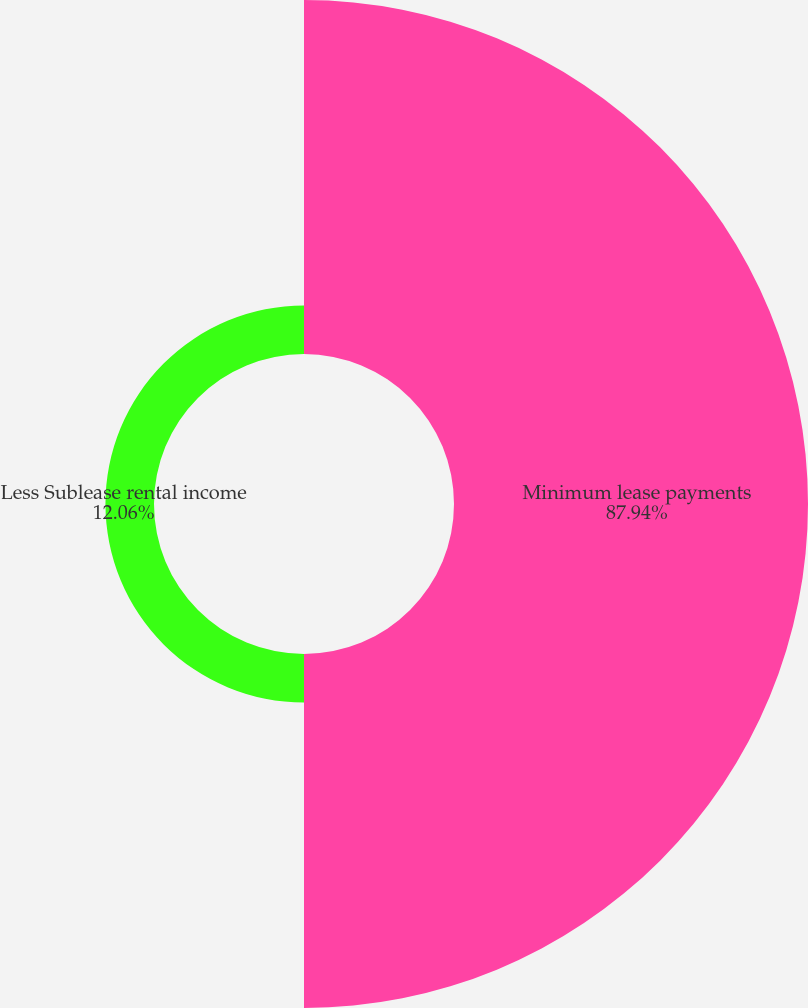<chart> <loc_0><loc_0><loc_500><loc_500><pie_chart><fcel>Minimum lease payments<fcel>Less Sublease rental income<nl><fcel>87.94%<fcel>12.06%<nl></chart> 